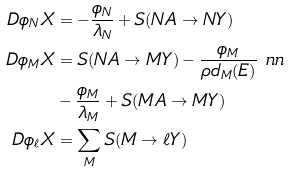Convert formula to latex. <formula><loc_0><loc_0><loc_500><loc_500>\ D { \phi _ { N } } { X } & = - \frac { \phi _ { N } } { \lambda _ { N } } + S ( N A \to N Y ) \\ \ D { \phi _ { M } } { X } & = S ( N A \to M Y ) - \frac { \phi _ { M } } { \rho d _ { M } ( E ) } \ n n \\ & - \frac { \phi _ { M } } { \lambda _ { M } } + S ( M A \to M Y ) \\ \ D { \phi _ { \ell } } { X } & = \sum _ { M } S ( M \to \ell Y )</formula> 